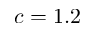Convert formula to latex. <formula><loc_0><loc_0><loc_500><loc_500>c = 1 . 2</formula> 